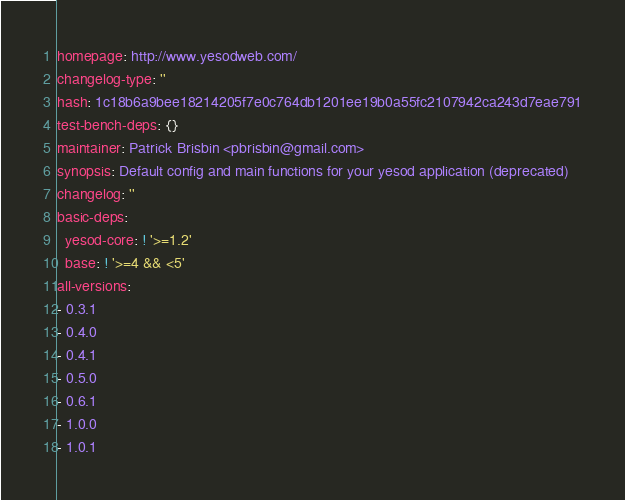<code> <loc_0><loc_0><loc_500><loc_500><_YAML_>homepage: http://www.yesodweb.com/
changelog-type: ''
hash: 1c18b6a9bee18214205f7e0c764db1201ee19b0a55fc2107942ca243d7eae791
test-bench-deps: {}
maintainer: Patrick Brisbin <pbrisbin@gmail.com>
synopsis: Default config and main functions for your yesod application (deprecated)
changelog: ''
basic-deps:
  yesod-core: ! '>=1.2'
  base: ! '>=4 && <5'
all-versions:
- 0.3.1
- 0.4.0
- 0.4.1
- 0.5.0
- 0.6.1
- 1.0.0
- 1.0.1</code> 